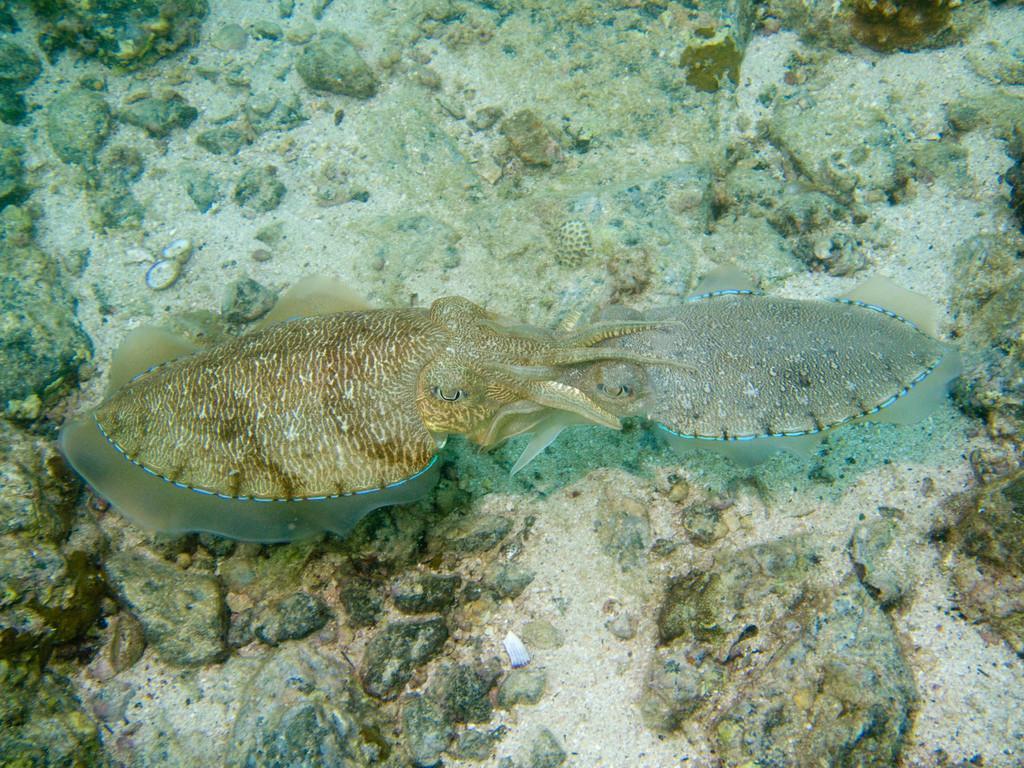Please provide a concise description of this image. In this image I can see two aquatic animals in water. I can also see some rocks. 